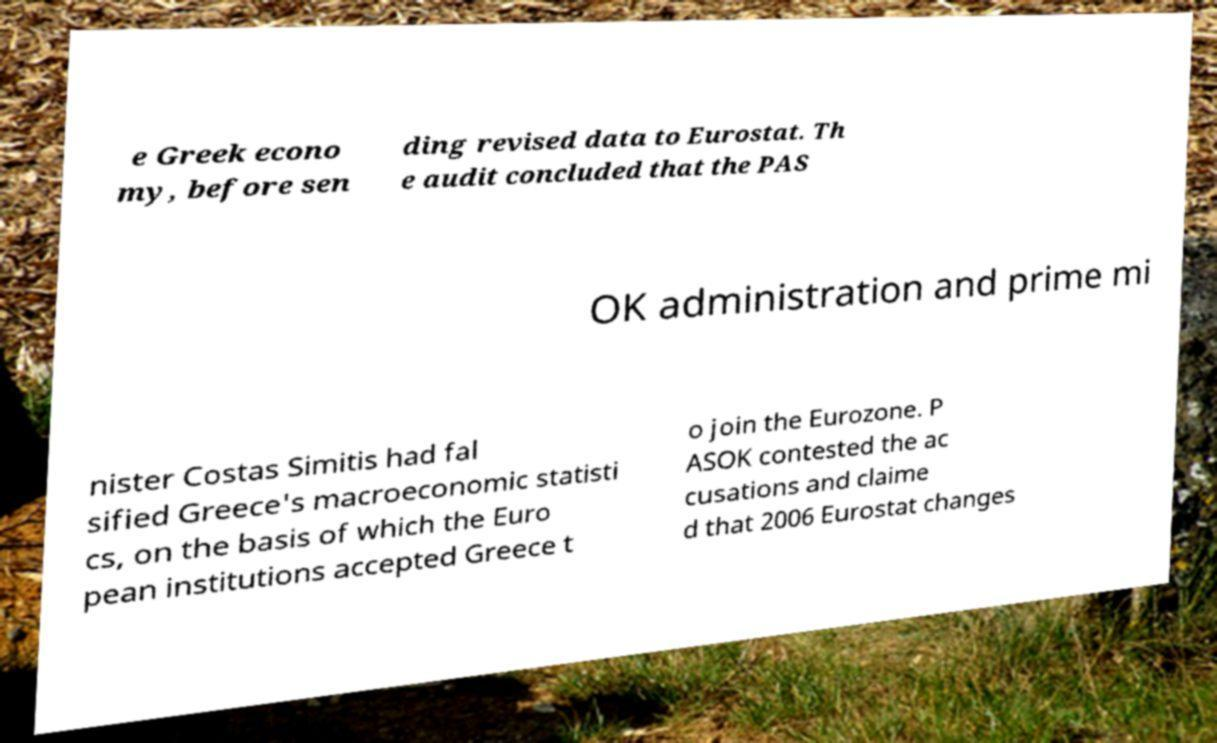For documentation purposes, I need the text within this image transcribed. Could you provide that? e Greek econo my, before sen ding revised data to Eurostat. Th e audit concluded that the PAS OK administration and prime mi nister Costas Simitis had fal sified Greece's macroeconomic statisti cs, on the basis of which the Euro pean institutions accepted Greece t o join the Eurozone. P ASOK contested the ac cusations and claime d that 2006 Eurostat changes 